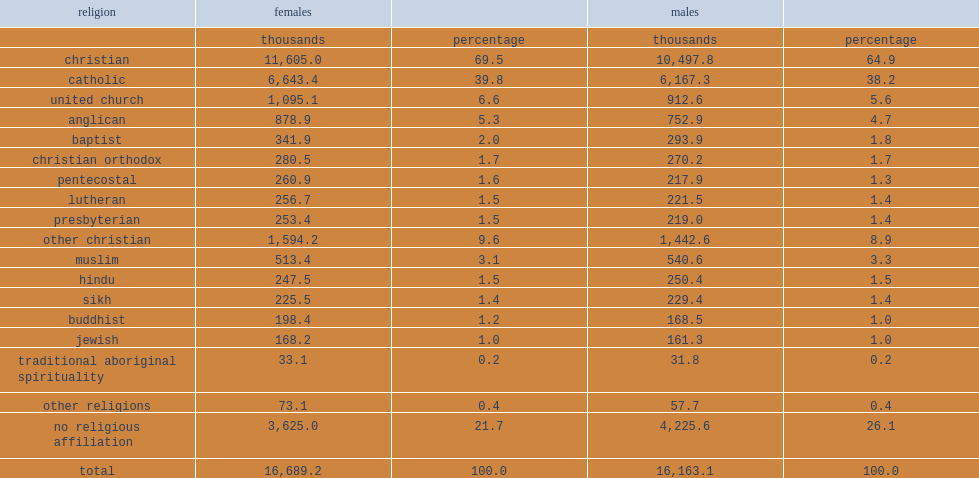Can you parse all the data within this table? {'header': ['religion', 'females', '', 'males', ''], 'rows': [['', 'thousands', 'percentage', 'thousands', 'percentage'], ['christian', '11,605.0', '69.5', '10,497.8', '64.9'], ['catholic', '6,643.4', '39.8', '6,167.3', '38.2'], ['united church', '1,095.1', '6.6', '912.6', '5.6'], ['anglican', '878.9', '5.3', '752.9', '4.7'], ['baptist', '341.9', '2.0', '293.9', '1.8'], ['christian orthodox', '280.5', '1.7', '270.2', '1.7'], ['pentecostal', '260.9', '1.6', '217.9', '1.3'], ['lutheran', '256.7', '1.5', '221.5', '1.4'], ['presbyterian', '253.4', '1.5', '219.0', '1.4'], ['other christian', '1,594.2', '9.6', '1,442.6', '8.9'], ['muslim', '513.4', '3.1', '540.6', '3.3'], ['hindu', '247.5', '1.5', '250.4', '1.5'], ['sikh', '225.5', '1.4', '229.4', '1.4'], ['buddhist', '198.4', '1.2', '168.5', '1.0'], ['jewish', '168.2', '1.0', '161.3', '1.0'], ['traditional aboriginal spirituality', '33.1', '0.2', '31.8', '0.2'], ['other religions', '73.1', '0.4', '57.7', '0.4'], ['no religious affiliation', '3,625.0', '21.7', '4,225.6', '26.1'], ['total', '16,689.2', '100.0', '16,163.1', '100.0']]} What was the percentage of the most common religion for females in 2011 of christian? 69.5. What was the percentage of the most common religion for males in 2011 of christian? 64.9. 